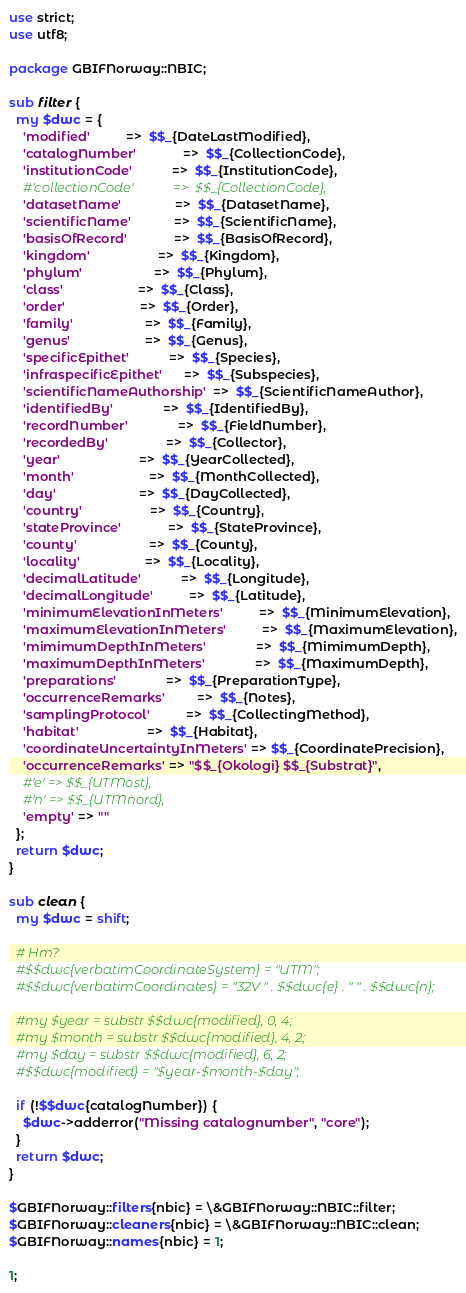Convert code to text. <code><loc_0><loc_0><loc_500><loc_500><_Perl_>use strict;
use utf8;

package GBIFNorway::NBIC;

sub filter {
  my $dwc = {
    'modified'          =>  $$_{DateLastModified},
    'catalogNumber'             =>  $$_{CollectionCode},
    'institutionCode'           =>  $$_{InstitutionCode},
    #'collectionCode'            =>  $$_{CollectionCode},
    'datasetName'               =>  $$_{DatasetName},
    'scientificName'            =>  $$_{ScientificName},
    'basisOfRecord'             =>  $$_{BasisOfRecord},
    'kingdom'                   =>  $$_{Kingdom},
    'phylum'                    =>  $$_{Phylum},
    'class'                     =>  $$_{Class},
    'order'                     =>  $$_{Order},
    'family'                    =>  $$_{Family},
    'genus'                     =>  $$_{Genus},
    'specificEpithet'           =>  $$_{Species},
    'infraspecificEpithet'      =>  $$_{Subspecies},
    'scientificNameAuthorship'  =>  $$_{ScientificNameAuthor},
    'identifiedBy'              =>  $$_{IdentifiedBy},
    'recordNumber'              =>  $$_{FieldNumber},
    'recordedBy'                =>  $$_{Collector},
    'year'                      =>  $$_{YearCollected},
    'month'                     =>  $$_{MonthCollected},
    'day'                       =>  $$_{DayCollected},
    'country'                   =>  $$_{Country},
    'stateProvince'             =>  $$_{StateProvince},
    'county'                    =>  $$_{County},
    'locality'                  =>  $$_{Locality},
    'decimalLatitude'           =>  $$_{Longitude},
    'decimalLongitude'          =>  $$_{Latitude},
    'minimumElevationInMeters'          =>  $$_{MinimumElevation},
    'maximumElevationInMeters'          =>  $$_{MaximumElevation},
    'mimimumDepthInMeters'              =>  $$_{MimimumDepth},
    'maximumDepthInMeters'              =>  $$_{MaximumDepth},
    'preparations'              =>  $$_{PreparationType},
    'occurrenceRemarks'         =>  $$_{Notes},
    'samplingProtocol'          =>  $$_{CollectingMethod},
    'habitat'                   =>  $$_{Habitat},
    'coordinateUncertaintyInMeters' => $$_{CoordinatePrecision},
    'occurrenceRemarks' => "$$_{Okologi} $$_{Substrat}",
    #'e' => $$_{UTMost},
    #'n' => $$_{UTMnord},
    'empty' => ""
  };
  return $dwc;
}

sub clean {
  my $dwc = shift;

  # Hm?
  #$$dwc{verbatimCoordinateSystem} = "UTM";
  #$$dwc{verbatimCoordinates} = "32V " . $$dwc{e} . " " . $$dwc{n};

  #my $year = substr $$dwc{modified}, 0, 4;
  #my $month = substr $$dwc{modified}, 4, 2;
  #my $day = substr $$dwc{modified}, 6, 2;
  #$$dwc{modified} = "$year-$month-$day";

  if (!$$dwc{catalogNumber}) {
    $dwc->adderror("Missing catalognumber", "core");
  }
  return $dwc;
}

$GBIFNorway::filters{nbic} = \&GBIFNorway::NBIC::filter;
$GBIFNorway::cleaners{nbic} = \&GBIFNorway::NBIC::clean;
$GBIFNorway::names{nbic} = 1;

1;

</code> 